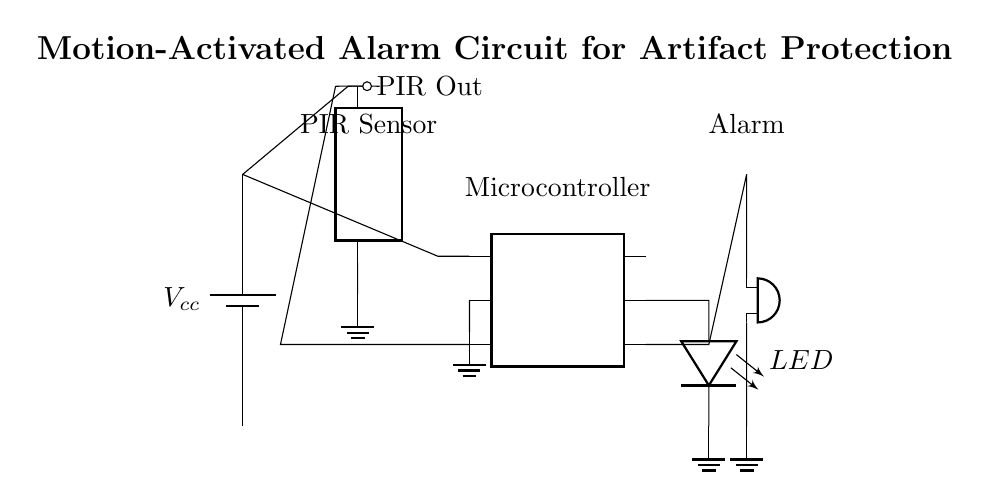What is the main purpose of this circuit? The circuit is designed to trigger an alarm when motion is detected, thereby protecting valuable artifacts.
Answer: Protecting artifacts What component detects motion? The component responsible for detecting motion is indicated in the diagram as the PIR sensor.
Answer: PIR sensor How many pins does the microcontroller have? The microcontroller in the diagram shows a total of six pins.
Answer: Six pins What indication does the circuit provide when motion is detected? The circuit activates an LED to indicate motion detection along with triggering the alarm.
Answer: LED indicator What type of alarm is shown in this circuit? The alarm in the circuit is represented as a buzzer, which emits sound when activated.
Answer: Buzzer Which component provides power to the circuit? The power supply in the circuit is provided by a battery, labeled as Vcc.
Answer: Battery How is the PIR sensor connected to the microcontroller? The PIR sensor is connected to the microcontroller through a signal output pin, enabling it to communicate motion detection.
Answer: Signal output pin 